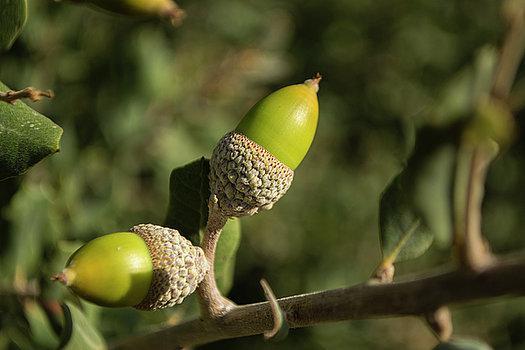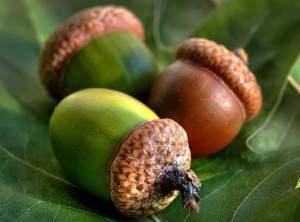The first image is the image on the left, the second image is the image on the right. For the images displayed, is the sentence "There are two green acorns and green acorn tops still attach to there branch." factually correct? Answer yes or no. Yes. 